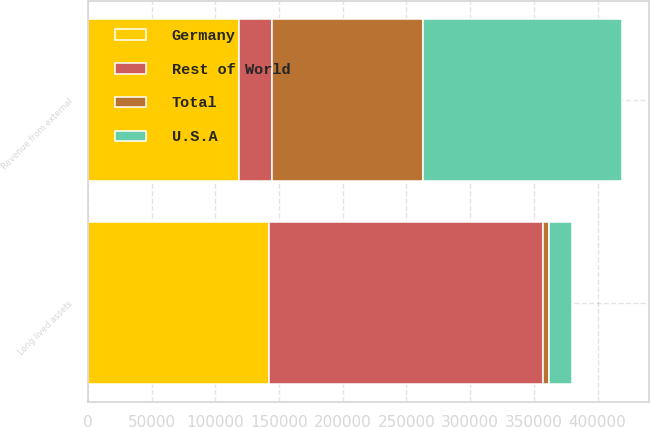Convert chart. <chart><loc_0><loc_0><loc_500><loc_500><stacked_bar_chart><ecel><fcel>Revenue from external<fcel>Long lived assets<nl><fcel>Germany<fcel>118511<fcel>142039<nl><fcel>U.S.A<fcel>155957<fcel>17938<nl><fcel>Rest of World<fcel>26099<fcel>215026<nl><fcel>Total<fcel>118511<fcel>4646<nl></chart> 